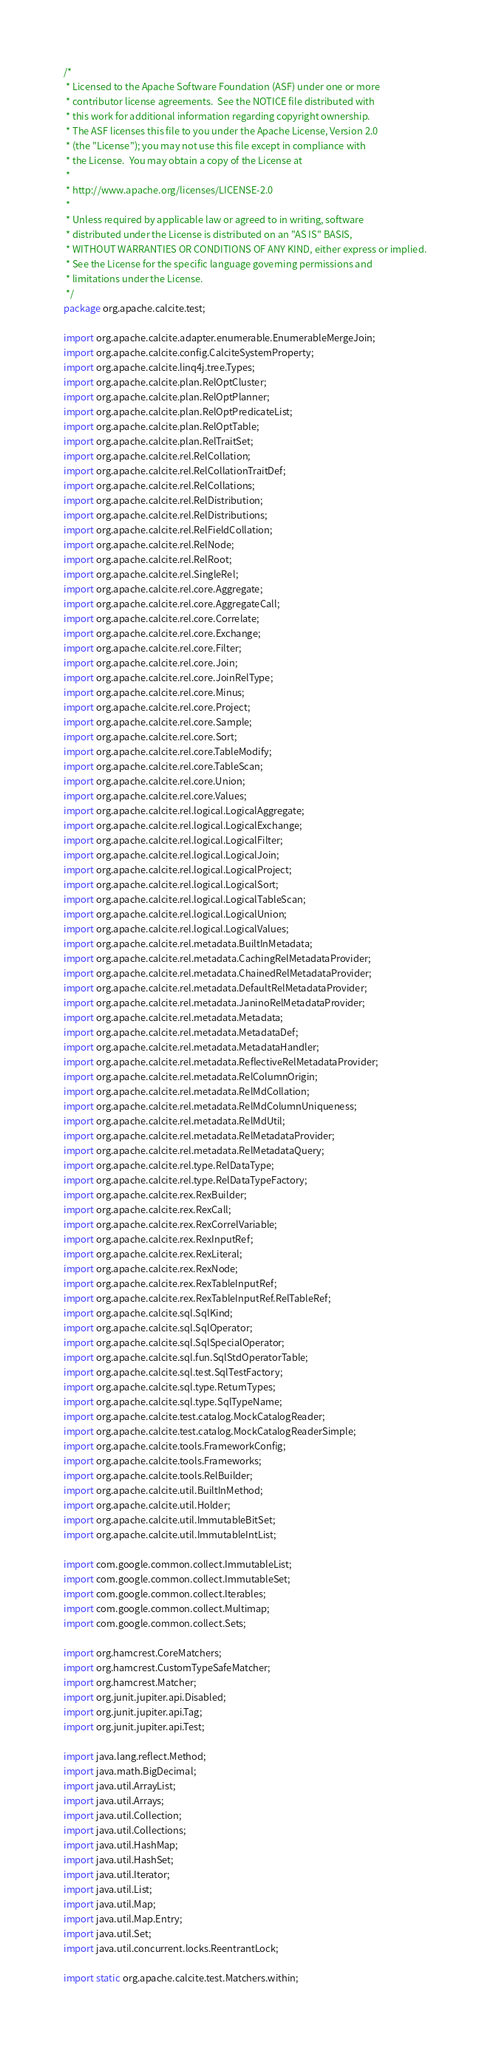Convert code to text. <code><loc_0><loc_0><loc_500><loc_500><_Java_>/*
 * Licensed to the Apache Software Foundation (ASF) under one or more
 * contributor license agreements.  See the NOTICE file distributed with
 * this work for additional information regarding copyright ownership.
 * The ASF licenses this file to you under the Apache License, Version 2.0
 * (the "License"); you may not use this file except in compliance with
 * the License.  You may obtain a copy of the License at
 *
 * http://www.apache.org/licenses/LICENSE-2.0
 *
 * Unless required by applicable law or agreed to in writing, software
 * distributed under the License is distributed on an "AS IS" BASIS,
 * WITHOUT WARRANTIES OR CONDITIONS OF ANY KIND, either express or implied.
 * See the License for the specific language governing permissions and
 * limitations under the License.
 */
package org.apache.calcite.test;

import org.apache.calcite.adapter.enumerable.EnumerableMergeJoin;
import org.apache.calcite.config.CalciteSystemProperty;
import org.apache.calcite.linq4j.tree.Types;
import org.apache.calcite.plan.RelOptCluster;
import org.apache.calcite.plan.RelOptPlanner;
import org.apache.calcite.plan.RelOptPredicateList;
import org.apache.calcite.plan.RelOptTable;
import org.apache.calcite.plan.RelTraitSet;
import org.apache.calcite.rel.RelCollation;
import org.apache.calcite.rel.RelCollationTraitDef;
import org.apache.calcite.rel.RelCollations;
import org.apache.calcite.rel.RelDistribution;
import org.apache.calcite.rel.RelDistributions;
import org.apache.calcite.rel.RelFieldCollation;
import org.apache.calcite.rel.RelNode;
import org.apache.calcite.rel.RelRoot;
import org.apache.calcite.rel.SingleRel;
import org.apache.calcite.rel.core.Aggregate;
import org.apache.calcite.rel.core.AggregateCall;
import org.apache.calcite.rel.core.Correlate;
import org.apache.calcite.rel.core.Exchange;
import org.apache.calcite.rel.core.Filter;
import org.apache.calcite.rel.core.Join;
import org.apache.calcite.rel.core.JoinRelType;
import org.apache.calcite.rel.core.Minus;
import org.apache.calcite.rel.core.Project;
import org.apache.calcite.rel.core.Sample;
import org.apache.calcite.rel.core.Sort;
import org.apache.calcite.rel.core.TableModify;
import org.apache.calcite.rel.core.TableScan;
import org.apache.calcite.rel.core.Union;
import org.apache.calcite.rel.core.Values;
import org.apache.calcite.rel.logical.LogicalAggregate;
import org.apache.calcite.rel.logical.LogicalExchange;
import org.apache.calcite.rel.logical.LogicalFilter;
import org.apache.calcite.rel.logical.LogicalJoin;
import org.apache.calcite.rel.logical.LogicalProject;
import org.apache.calcite.rel.logical.LogicalSort;
import org.apache.calcite.rel.logical.LogicalTableScan;
import org.apache.calcite.rel.logical.LogicalUnion;
import org.apache.calcite.rel.logical.LogicalValues;
import org.apache.calcite.rel.metadata.BuiltInMetadata;
import org.apache.calcite.rel.metadata.CachingRelMetadataProvider;
import org.apache.calcite.rel.metadata.ChainedRelMetadataProvider;
import org.apache.calcite.rel.metadata.DefaultRelMetadataProvider;
import org.apache.calcite.rel.metadata.JaninoRelMetadataProvider;
import org.apache.calcite.rel.metadata.Metadata;
import org.apache.calcite.rel.metadata.MetadataDef;
import org.apache.calcite.rel.metadata.MetadataHandler;
import org.apache.calcite.rel.metadata.ReflectiveRelMetadataProvider;
import org.apache.calcite.rel.metadata.RelColumnOrigin;
import org.apache.calcite.rel.metadata.RelMdCollation;
import org.apache.calcite.rel.metadata.RelMdColumnUniqueness;
import org.apache.calcite.rel.metadata.RelMdUtil;
import org.apache.calcite.rel.metadata.RelMetadataProvider;
import org.apache.calcite.rel.metadata.RelMetadataQuery;
import org.apache.calcite.rel.type.RelDataType;
import org.apache.calcite.rel.type.RelDataTypeFactory;
import org.apache.calcite.rex.RexBuilder;
import org.apache.calcite.rex.RexCall;
import org.apache.calcite.rex.RexCorrelVariable;
import org.apache.calcite.rex.RexInputRef;
import org.apache.calcite.rex.RexLiteral;
import org.apache.calcite.rex.RexNode;
import org.apache.calcite.rex.RexTableInputRef;
import org.apache.calcite.rex.RexTableInputRef.RelTableRef;
import org.apache.calcite.sql.SqlKind;
import org.apache.calcite.sql.SqlOperator;
import org.apache.calcite.sql.SqlSpecialOperator;
import org.apache.calcite.sql.fun.SqlStdOperatorTable;
import org.apache.calcite.sql.test.SqlTestFactory;
import org.apache.calcite.sql.type.ReturnTypes;
import org.apache.calcite.sql.type.SqlTypeName;
import org.apache.calcite.test.catalog.MockCatalogReader;
import org.apache.calcite.test.catalog.MockCatalogReaderSimple;
import org.apache.calcite.tools.FrameworkConfig;
import org.apache.calcite.tools.Frameworks;
import org.apache.calcite.tools.RelBuilder;
import org.apache.calcite.util.BuiltInMethod;
import org.apache.calcite.util.Holder;
import org.apache.calcite.util.ImmutableBitSet;
import org.apache.calcite.util.ImmutableIntList;

import com.google.common.collect.ImmutableList;
import com.google.common.collect.ImmutableSet;
import com.google.common.collect.Iterables;
import com.google.common.collect.Multimap;
import com.google.common.collect.Sets;

import org.hamcrest.CoreMatchers;
import org.hamcrest.CustomTypeSafeMatcher;
import org.hamcrest.Matcher;
import org.junit.jupiter.api.Disabled;
import org.junit.jupiter.api.Tag;
import org.junit.jupiter.api.Test;

import java.lang.reflect.Method;
import java.math.BigDecimal;
import java.util.ArrayList;
import java.util.Arrays;
import java.util.Collection;
import java.util.Collections;
import java.util.HashMap;
import java.util.HashSet;
import java.util.Iterator;
import java.util.List;
import java.util.Map;
import java.util.Map.Entry;
import java.util.Set;
import java.util.concurrent.locks.ReentrantLock;

import static org.apache.calcite.test.Matchers.within;
</code> 